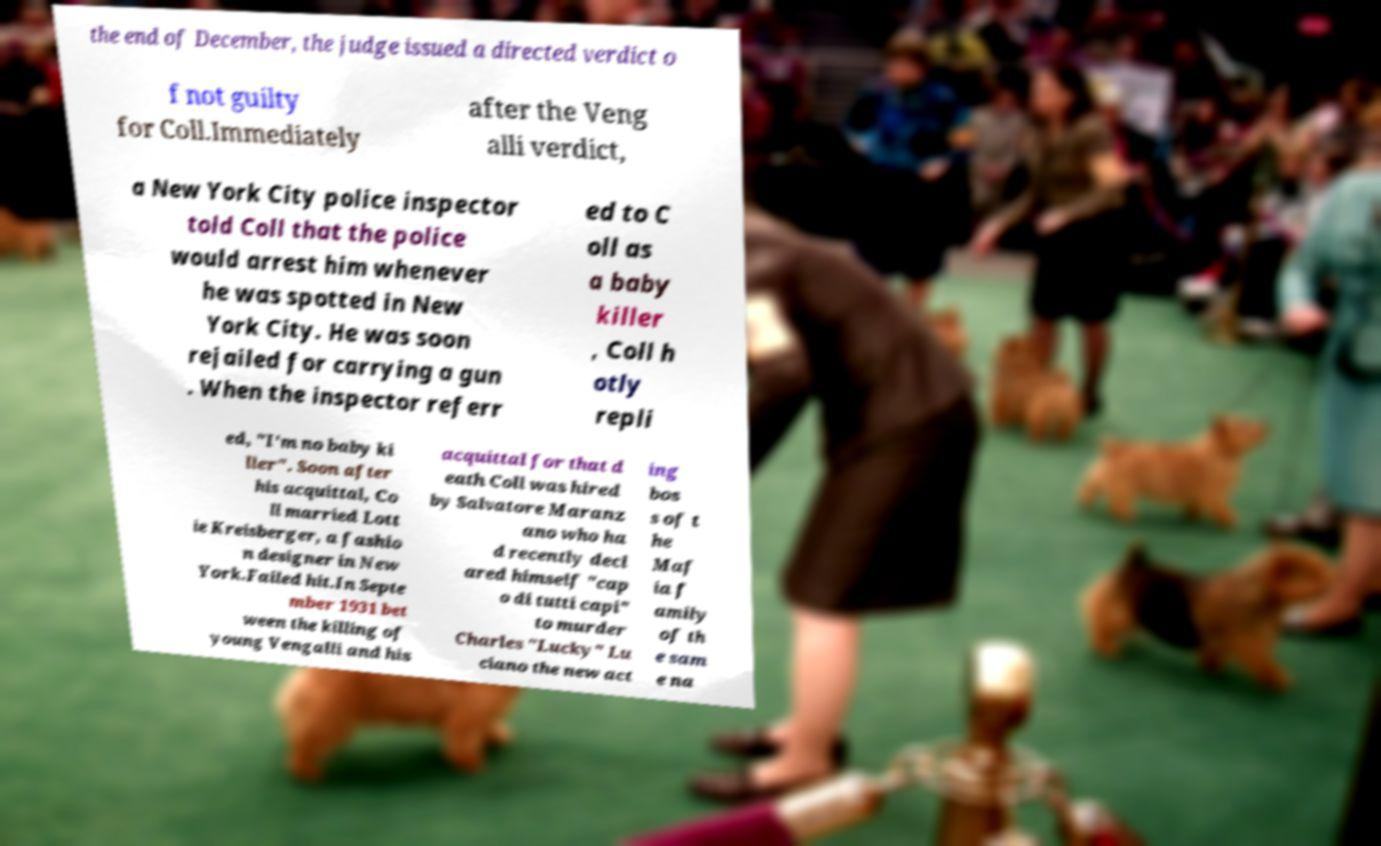Please identify and transcribe the text found in this image. the end of December, the judge issued a directed verdict o f not guilty for Coll.Immediately after the Veng alli verdict, a New York City police inspector told Coll that the police would arrest him whenever he was spotted in New York City. He was soon rejailed for carrying a gun . When the inspector referr ed to C oll as a baby killer , Coll h otly repli ed, "I'm no baby ki ller". Soon after his acquittal, Co ll married Lott ie Kreisberger, a fashio n designer in New York.Failed hit.In Septe mber 1931 bet ween the killing of young Vengalli and his acquittal for that d eath Coll was hired by Salvatore Maranz ano who ha d recently decl ared himself "cap o di tutti capi" to murder Charles "Lucky" Lu ciano the new act ing bos s of t he Maf ia f amily of th e sam e na 